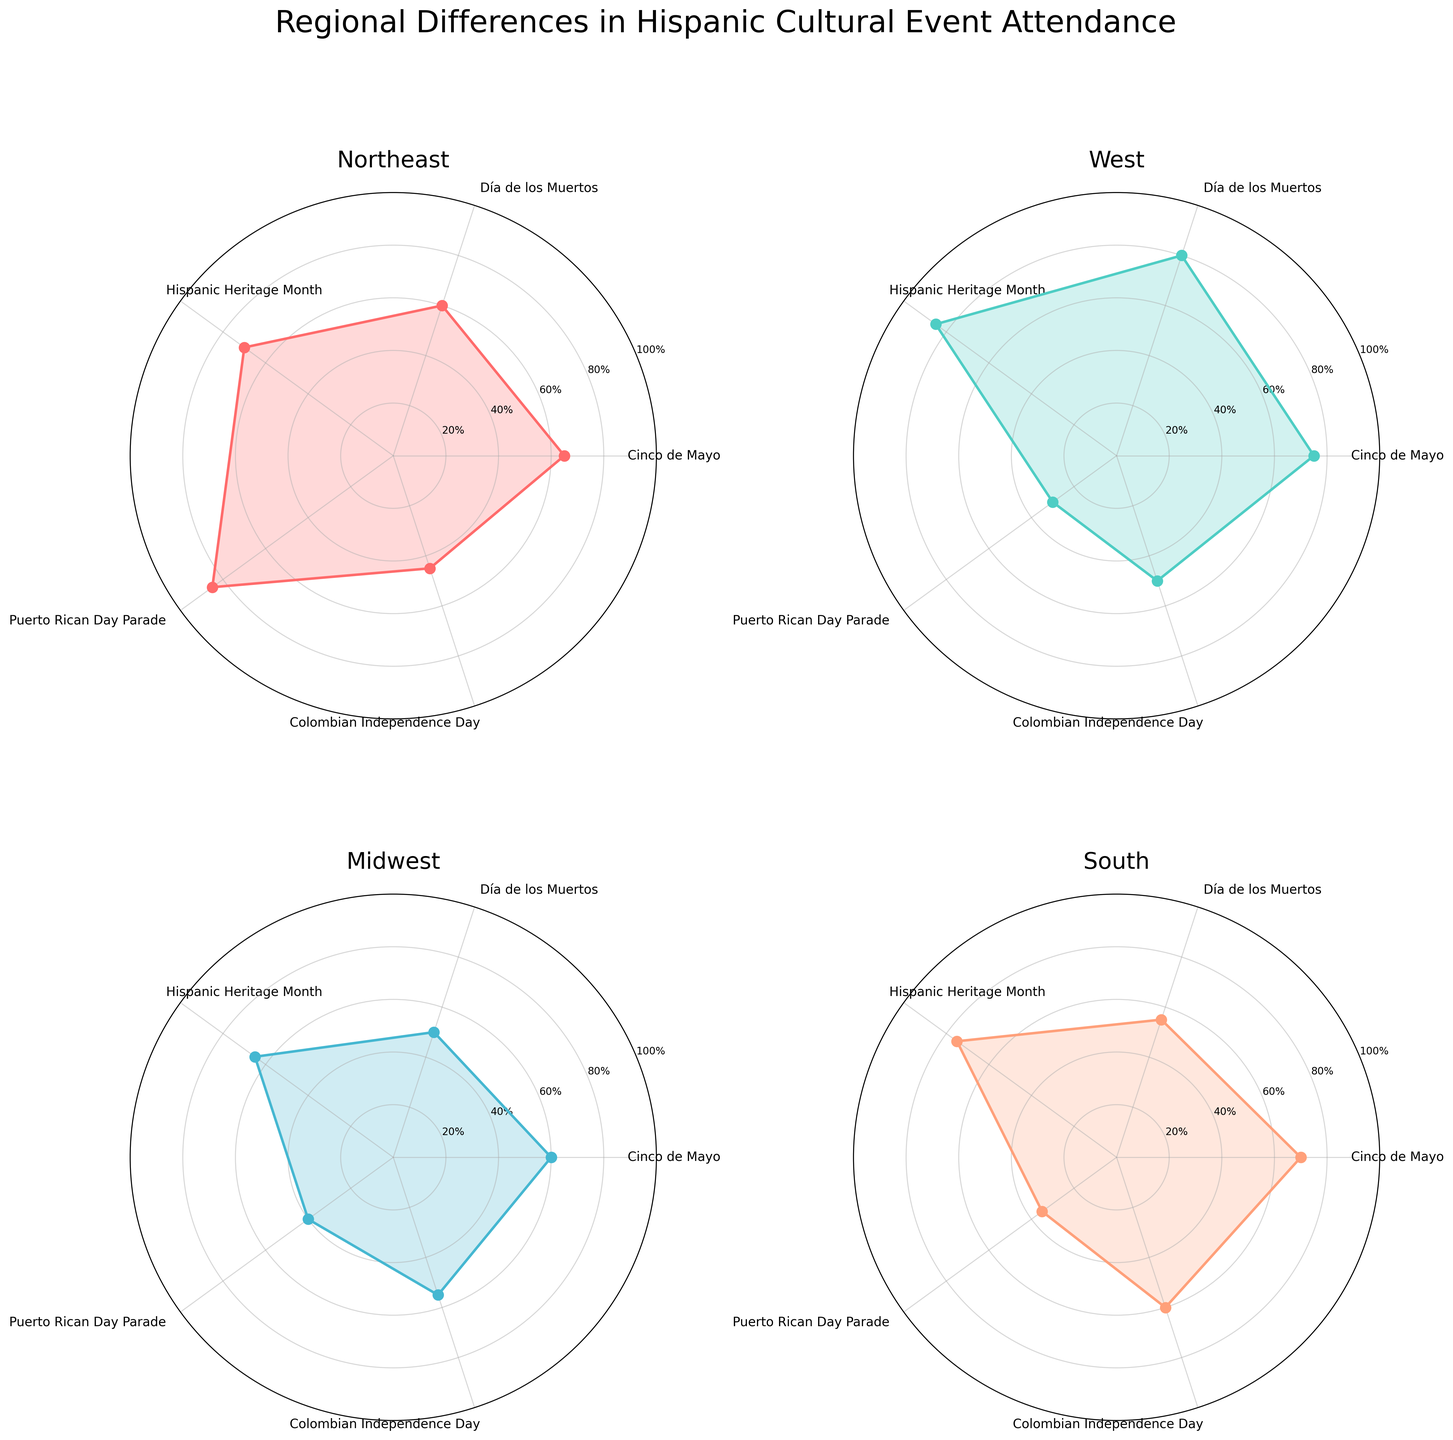What is the event with the highest attendance percentage in the Northeast region? The Northeast region's subplot shows the Puerto Rican Day Parade with an 85% attendance rate, which is the highest among other events in that region.
Answer: Puerto Rican Day Parade Which region has the lowest attendance percentage for the Puerto Rican Day Parade? By examining the attendance percentages for the Puerto Rican Day Parade in each region's subplot, the West region has the lowest at 30%.
Answer: West How do the attendance percentages for Cinco de Mayo compare between the West and Midwest regions? In the West region's subplot, the Cinco de Mayo attendance is 75%, while in the Midwest region, it's 60%. Therefore, the attendance percentage is higher in the West compared to the Midwest.
Answer: West has higher What is the average attendance percentage for Hispanic Heritage Month across all regions? Summing the attendance percentages for Hispanic Heritage Month from each subplot: Northeast (70%), West (85%), Midwest (65%), South (75%). The total is 70 + 85 + 65 + 75 = 295; dividing by 4 regions gives 295 / 4 = 73.75%.
Answer: 73.75% What event has the most consistent attendance percentage across all regions? Looking at each event across the subplots, Colombian Independence Day has percentages of 45% (Northeast), 50% (West), 55% (Midwest), and 60% (South), showing the least variance.
Answer: Colombian Independence Day Which region has the most varied attendance percentages for different events? In the West region's subplot, the range of attendance percentages spans from 30% (Puerto Rican Day Parade) to 85% (Hispanic Heritage Month), a range of 55%. This shows the highest variation compared to other regions.
Answer: West Which event has the lowest attendance in the South? In the South region's subplot, the Puerto Rican Day Parade has the lowest attendance at 35%.
Answer: Puerto Rican Day Parade How does the attendance for Día de los Muertos in the South compare to its attendance in the West? The South's subplot shows a 55% attendance for Día de los Muertos, while the West's subplot shows 80%. The West has a higher attendance.
Answer: West has higher What is the difference in attendance for the Hispanic Heritage Month between the Northeast and Midwest regions? The Northeast's subplot shows a 70% attendance for Hispanic Heritage Month, while the Midwest's subplot shows 65%. The difference is 70% - 65% = 5%.
Answer: 5% Which region has the highest average event attendance? Calculating the average for each region: Northeast (65+60+70+85+45)/5 = 65%, West (75+80+85+30+50)/5 = 64%, Midwest (60+50+65+40+55)/5 = 54%, South (70+55+75+35+60)/5 = 59%. Northeast has the highest average attendance.
Answer: Northeast 